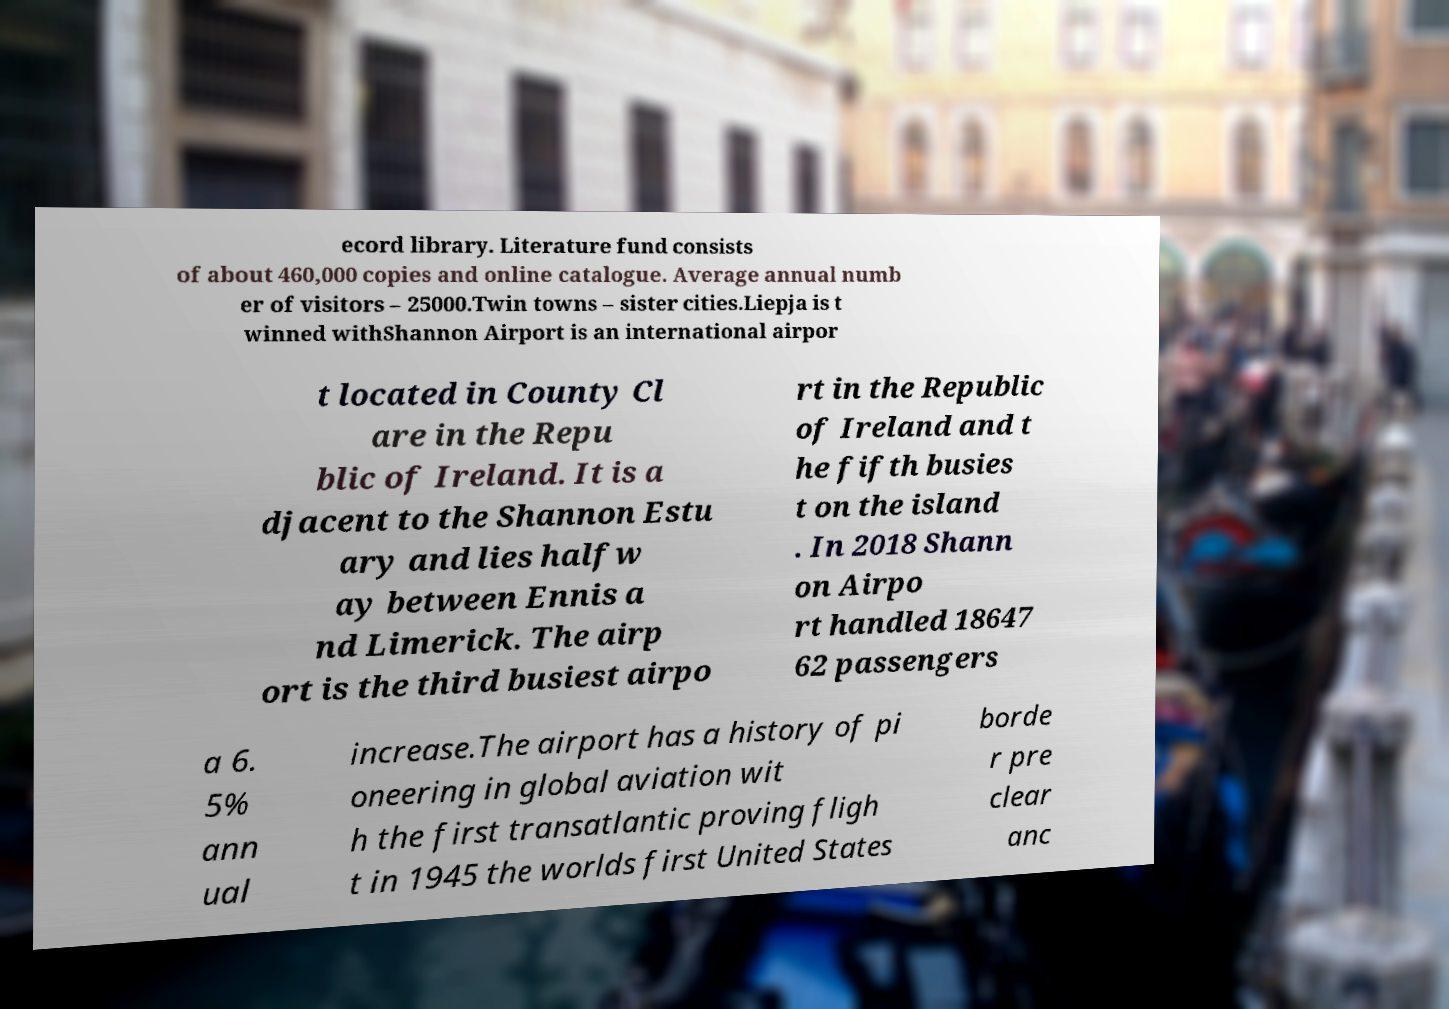Can you read and provide the text displayed in the image?This photo seems to have some interesting text. Can you extract and type it out for me? ecord library. Literature fund consists of about 460,000 copies and online catalogue. Average annual numb er of visitors – 25000.Twin towns – sister cities.Liepja is t winned withShannon Airport is an international airpor t located in County Cl are in the Repu blic of Ireland. It is a djacent to the Shannon Estu ary and lies halfw ay between Ennis a nd Limerick. The airp ort is the third busiest airpo rt in the Republic of Ireland and t he fifth busies t on the island . In 2018 Shann on Airpo rt handled 18647 62 passengers a 6. 5% ann ual increase.The airport has a history of pi oneering in global aviation wit h the first transatlantic proving fligh t in 1945 the worlds first United States borde r pre clear anc 